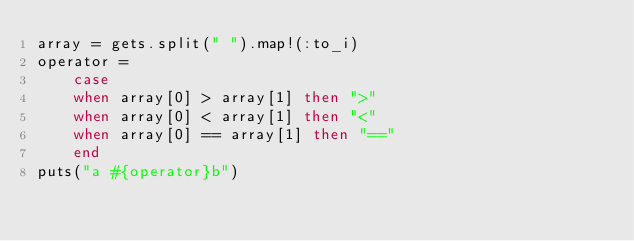Convert code to text. <code><loc_0><loc_0><loc_500><loc_500><_Ruby_>array = gets.split(" ").map!(:to_i)
operator = 
    case
    when array[0] > array[1] then ">"
    when array[0] < array[1] then "<"
    when array[0] == array[1] then "=="
    end
puts("a #{operator}b")</code> 